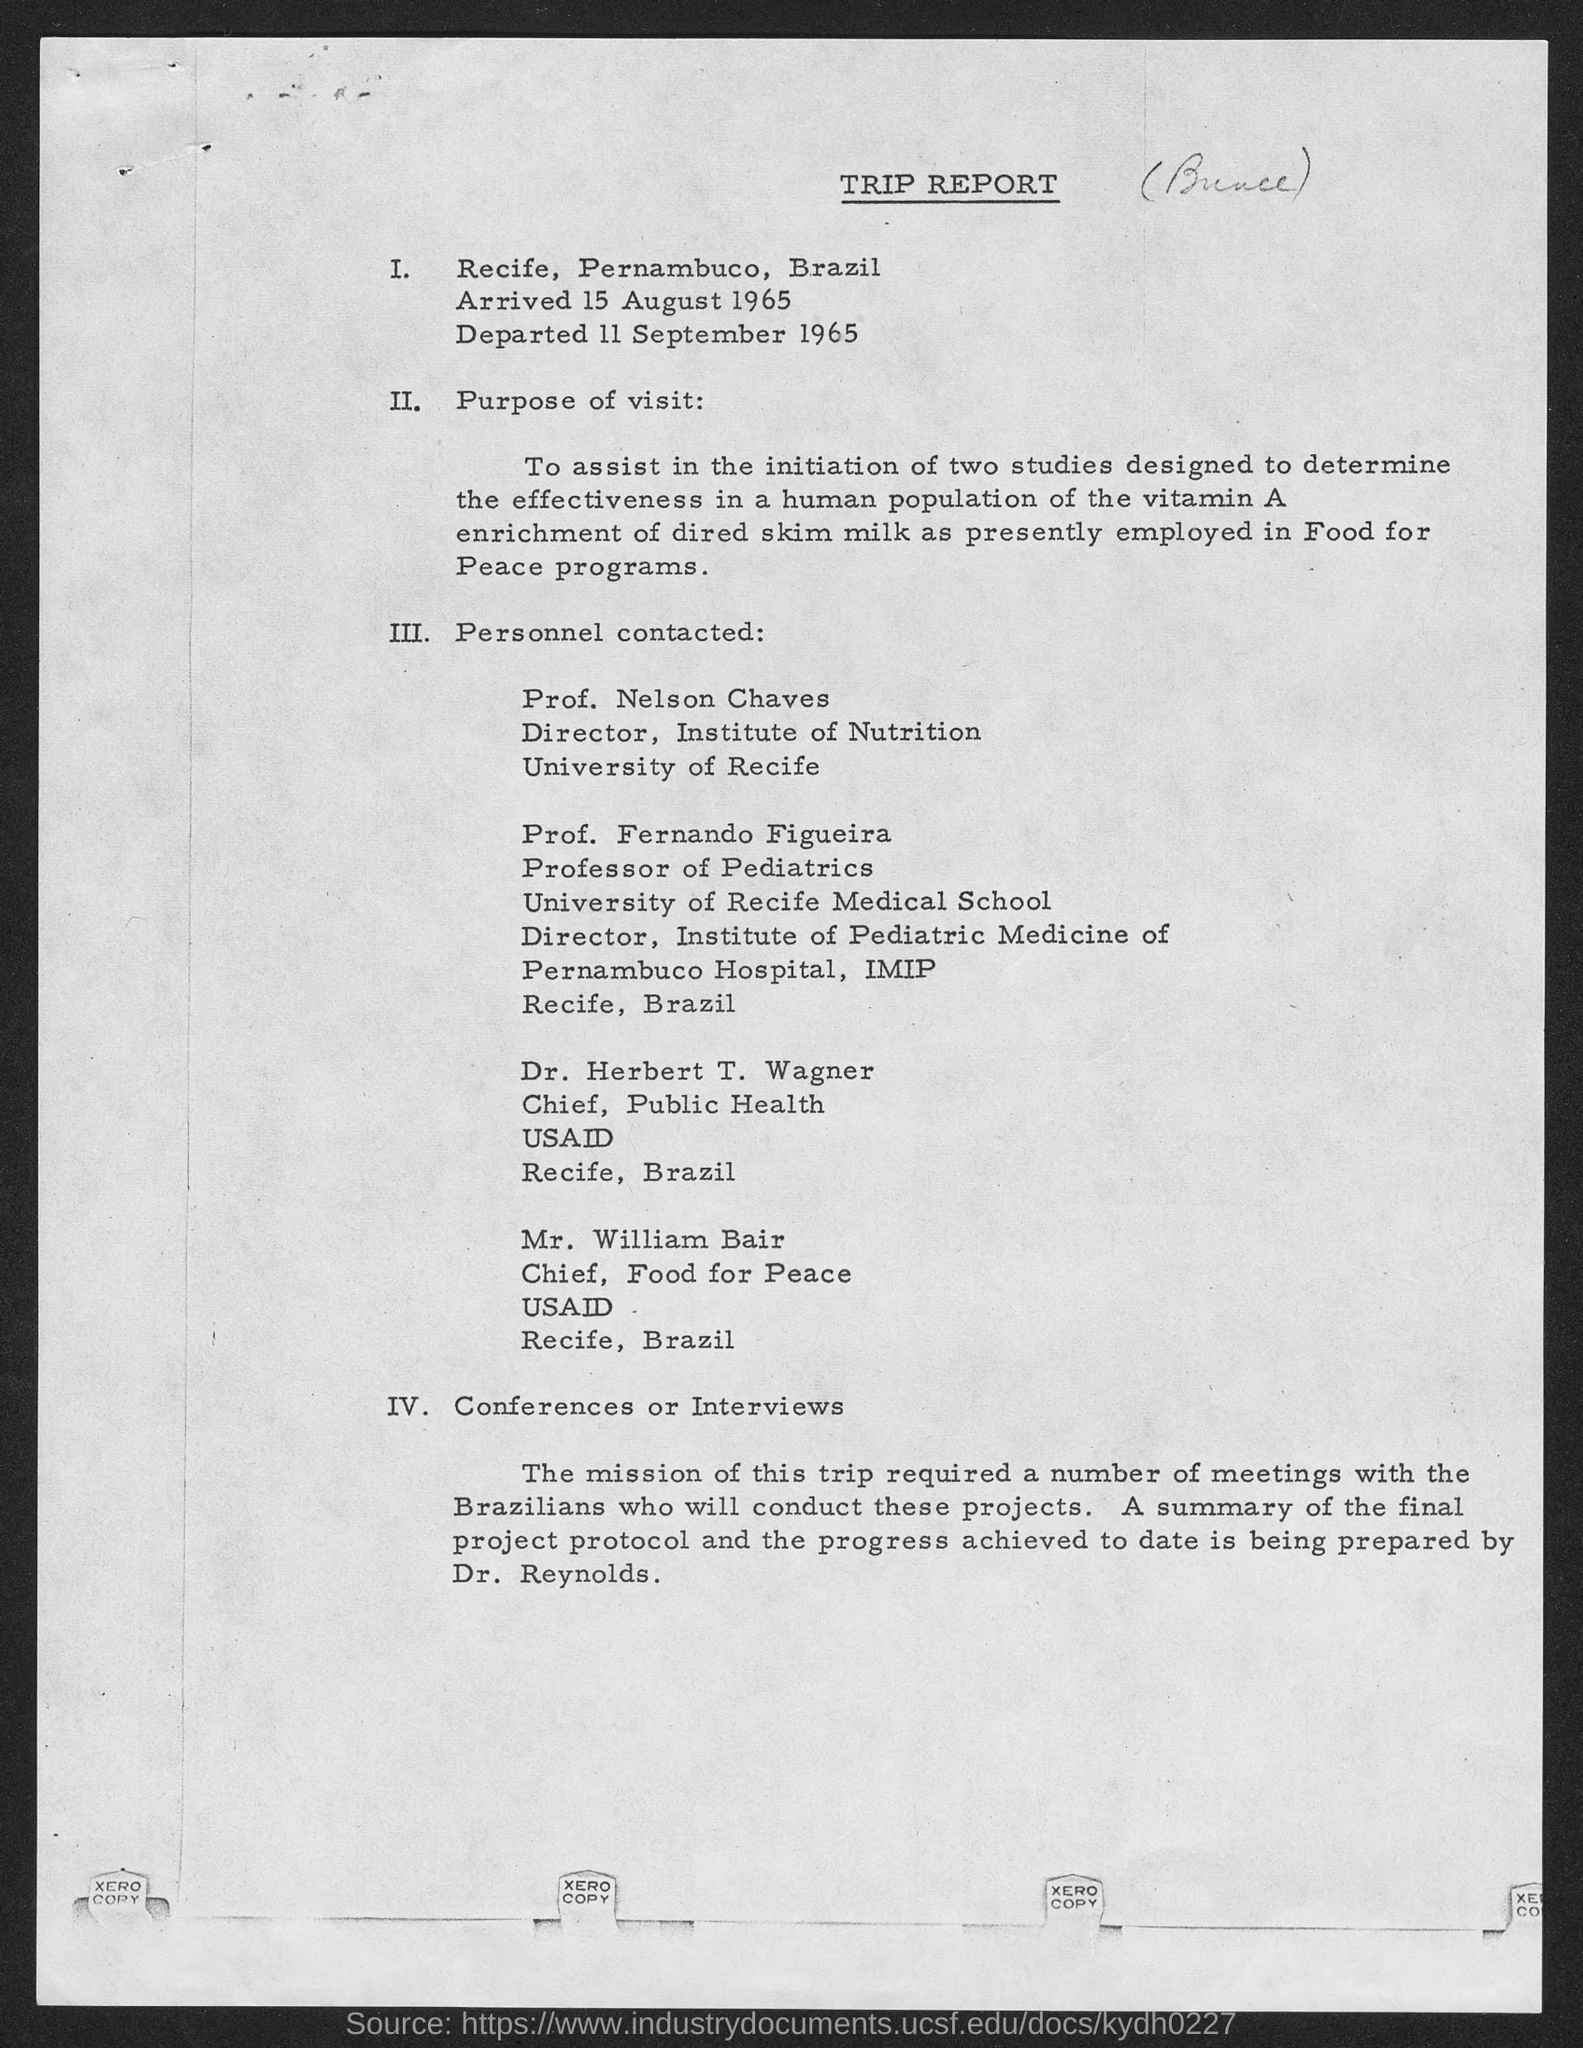Identify some key points in this picture. Dr. Herbert T. Wagner holds the position of Chief at [insert position]. Mr. William Bair holds the position of Chief. The name of the report is Trip Report. Prof. Fernando Figueira holds the position of Professor of Pediatrics. Professor Nelson Chaves holds the position of Director. 